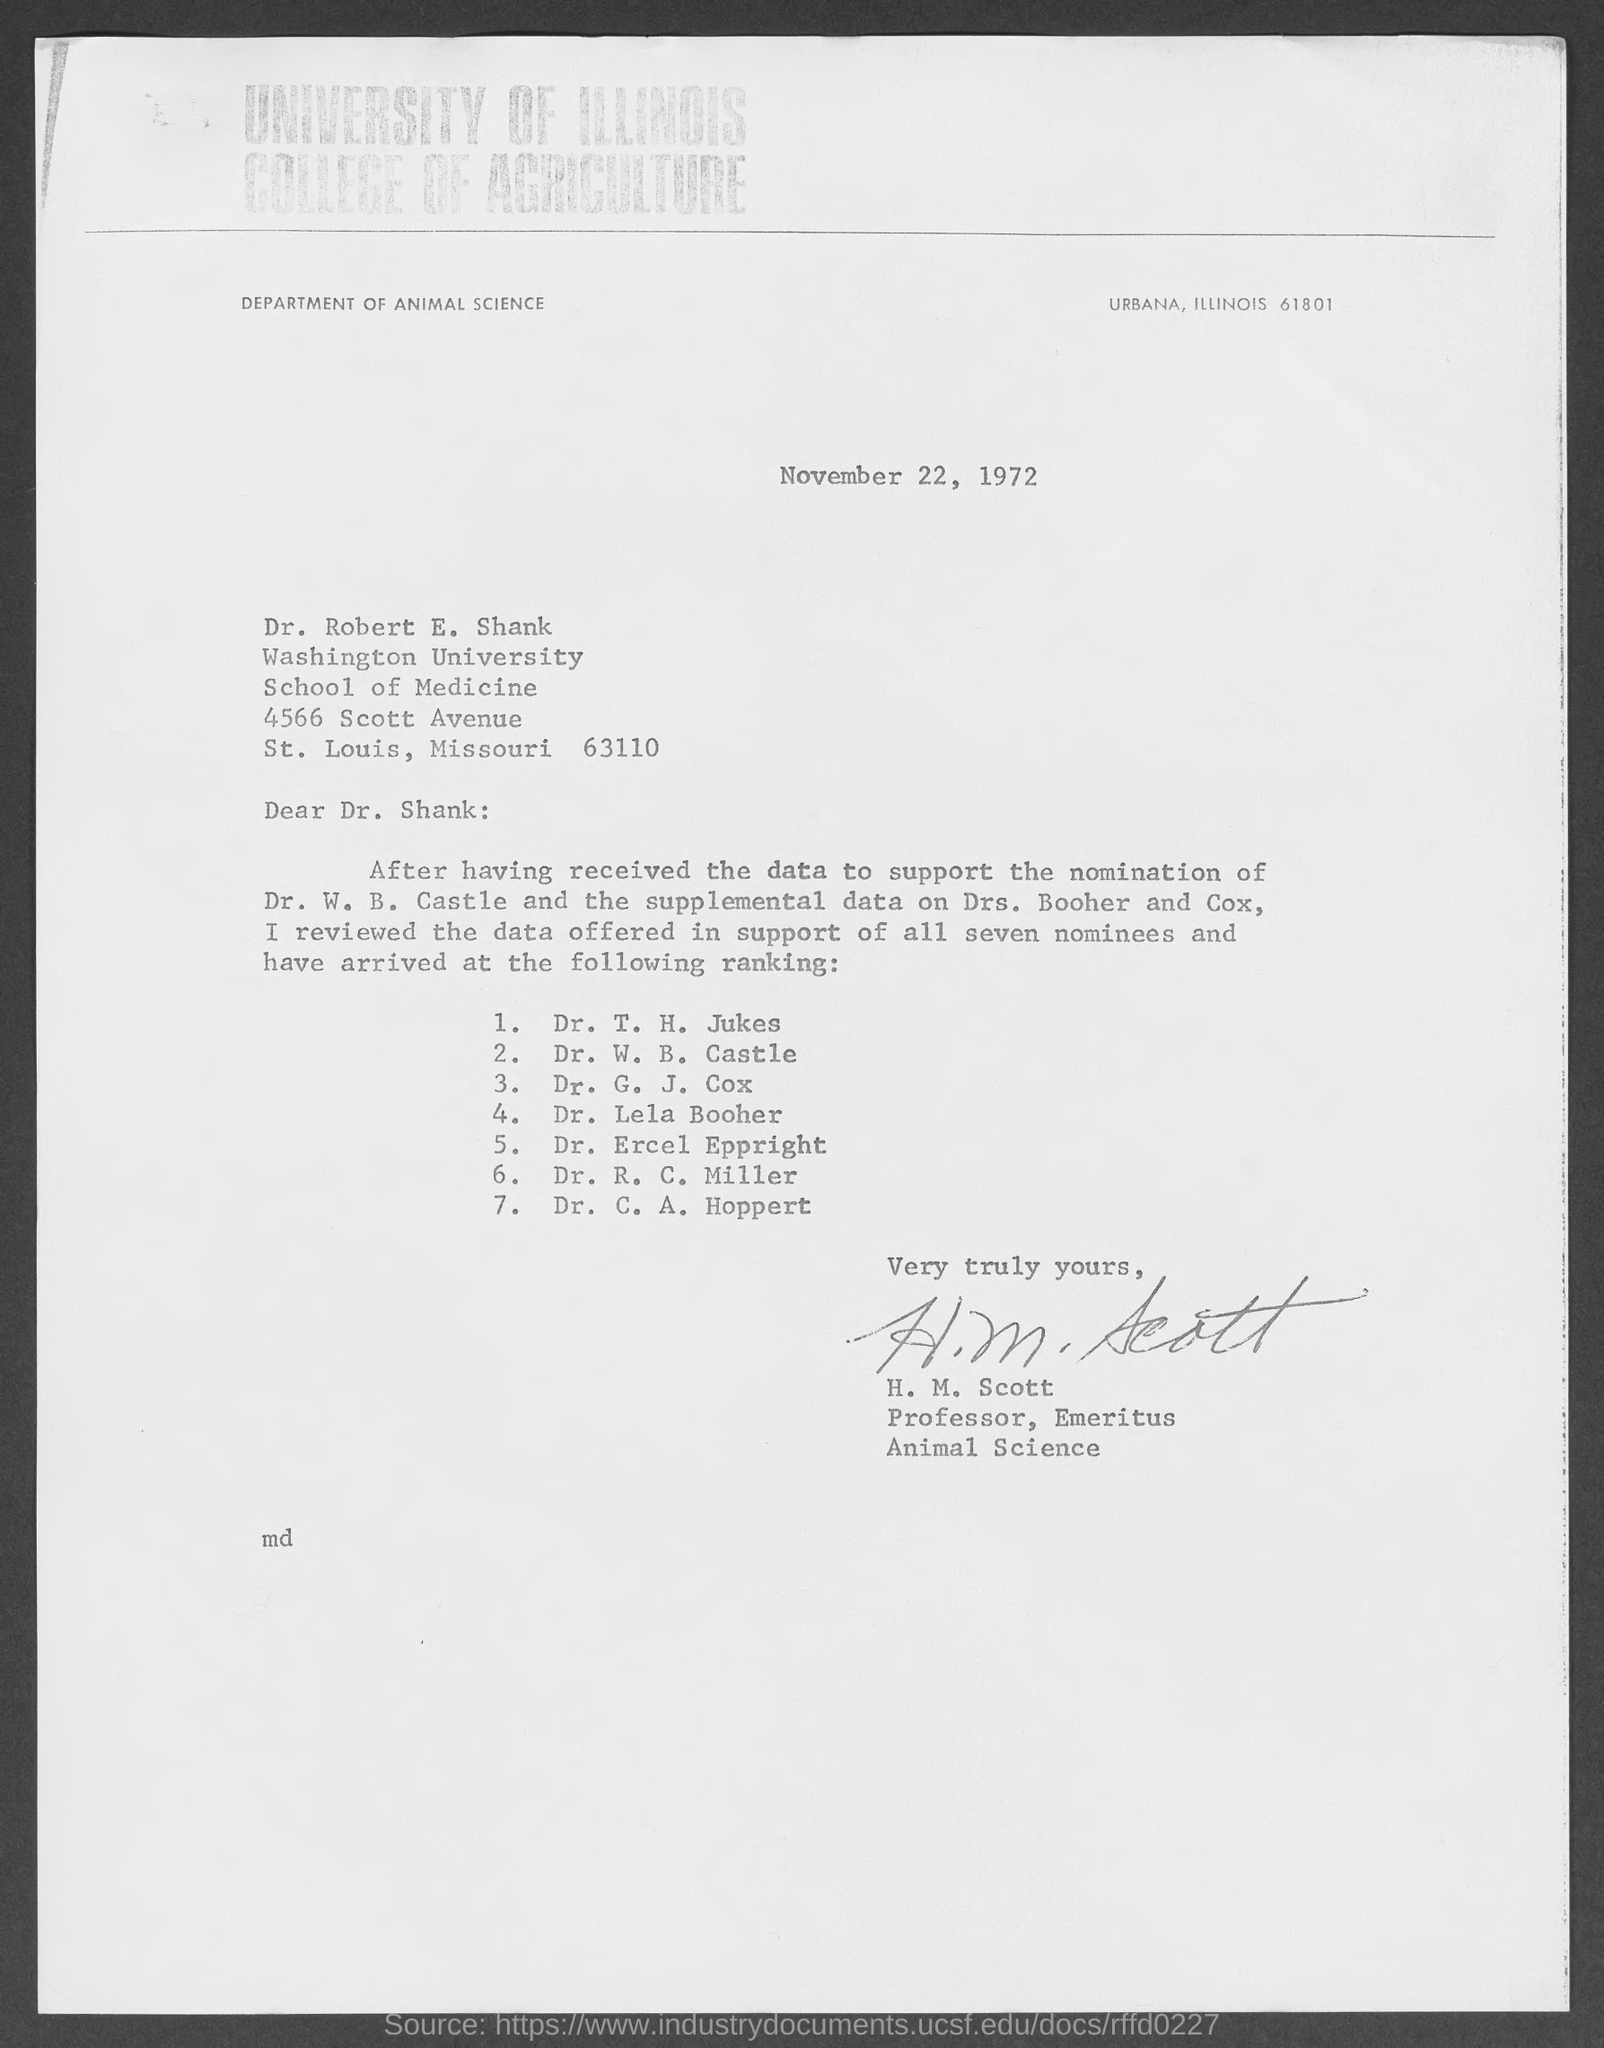Give some essential details in this illustration. The letter was written by H. M. Scott. The letter, dated November 22, 1972, indicates... Dr. Robert E. Shank is affiliated with Washington University. 